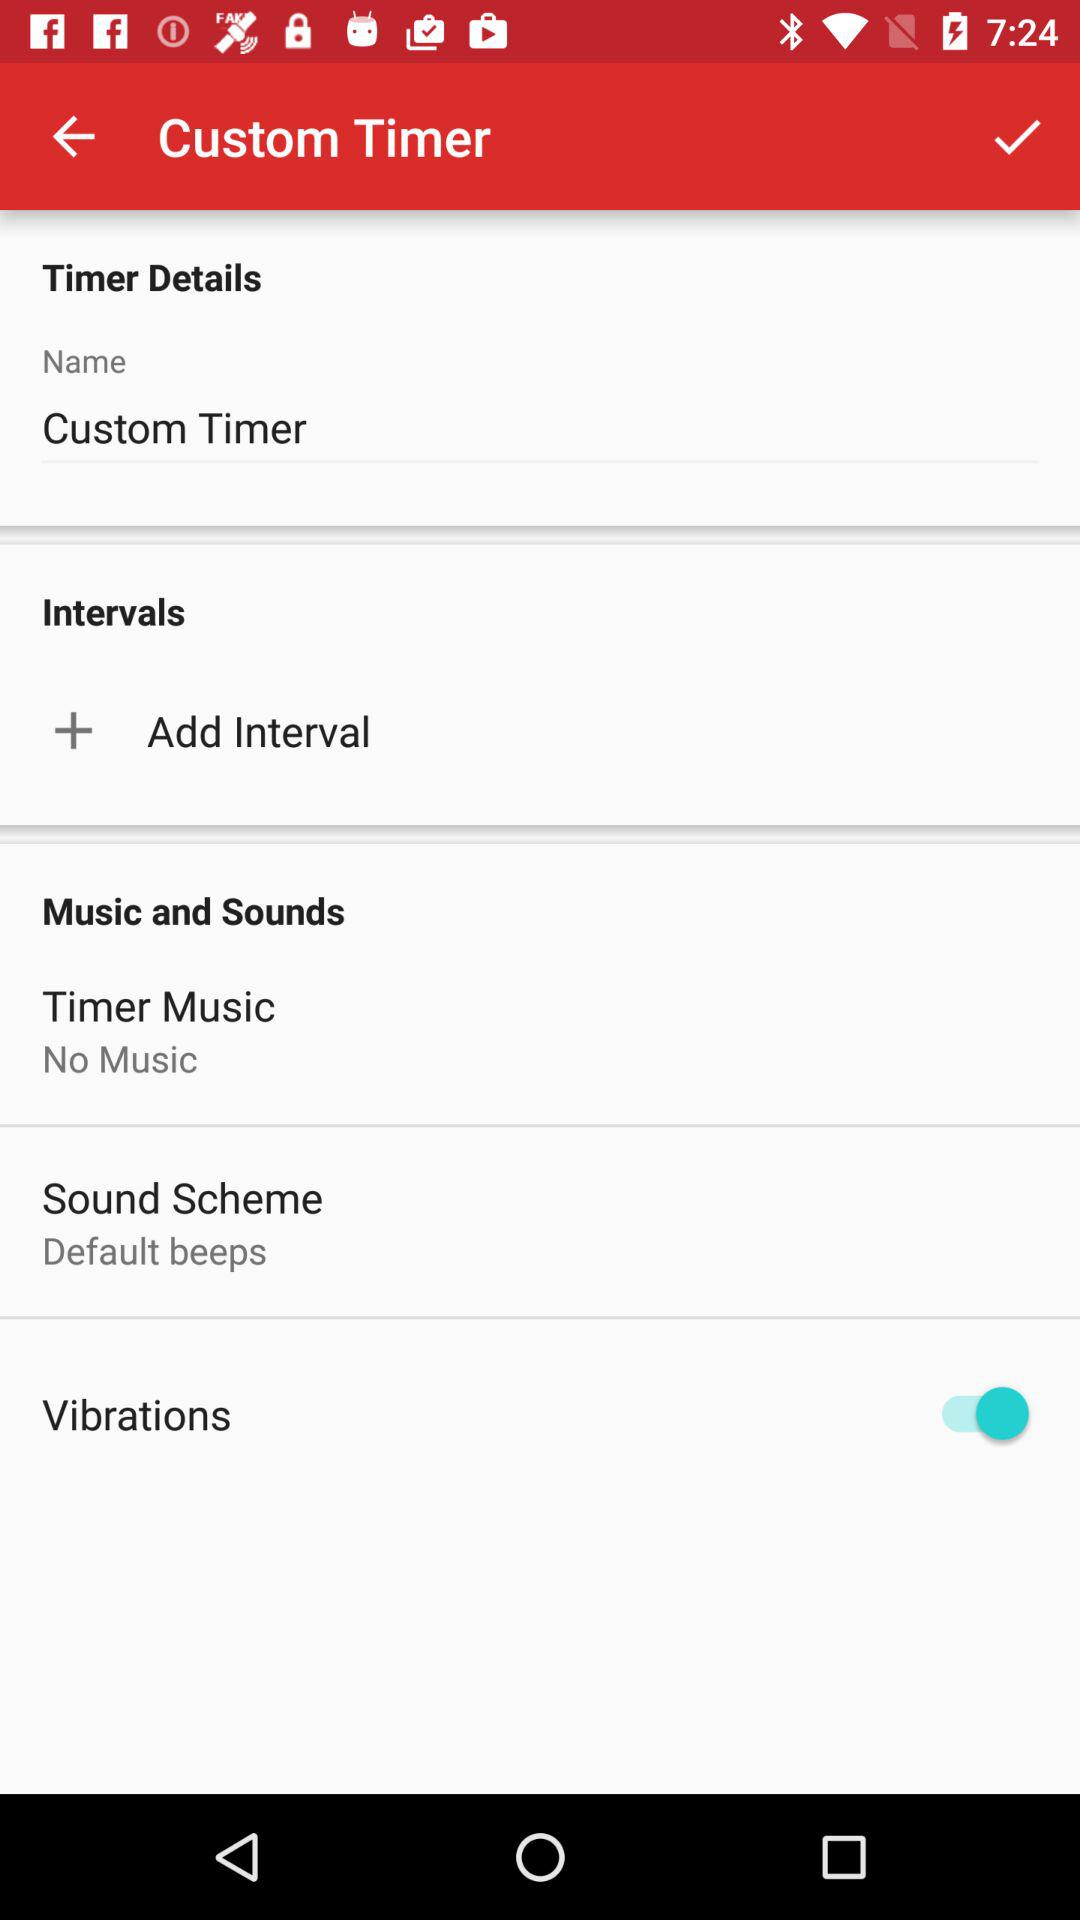What is the sound scheme? The sound scheme is "Default beeps". 